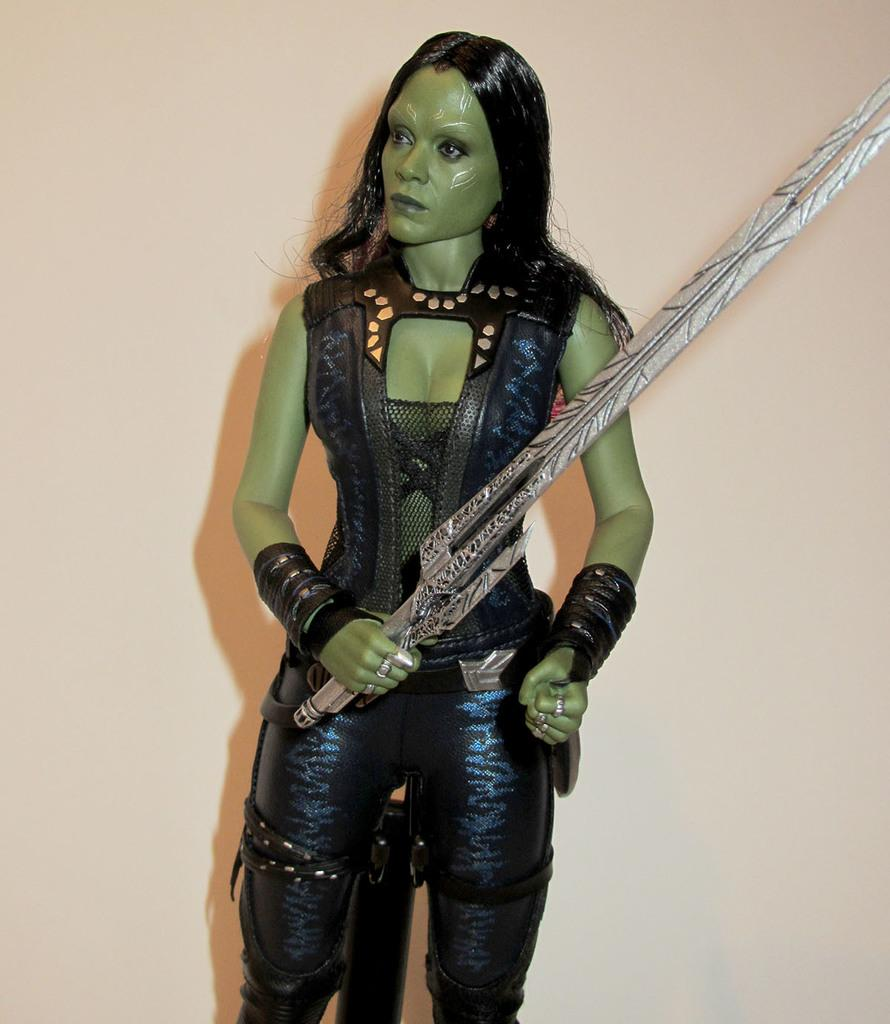What is the woman holding in the image? The woman is holding a sword in the image. Where is the woman located in the image? The woman is in the center of the image. What can be seen in the background of the image? There is a wall in the background of the image. What type of holiday is being celebrated in the image? There is no indication of a holiday being celebrated in the image. Can you see a hole in the wall in the background of the image? There is no hole visible in the wall in the background of the image. 